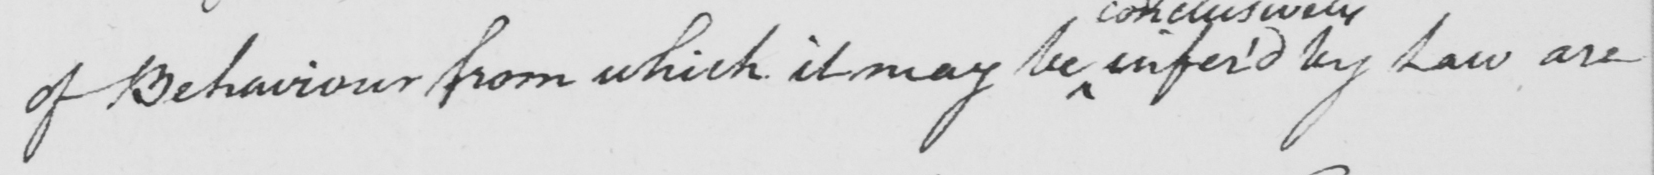What does this handwritten line say? of Behaviour from which it may be infer ' d by Law are 